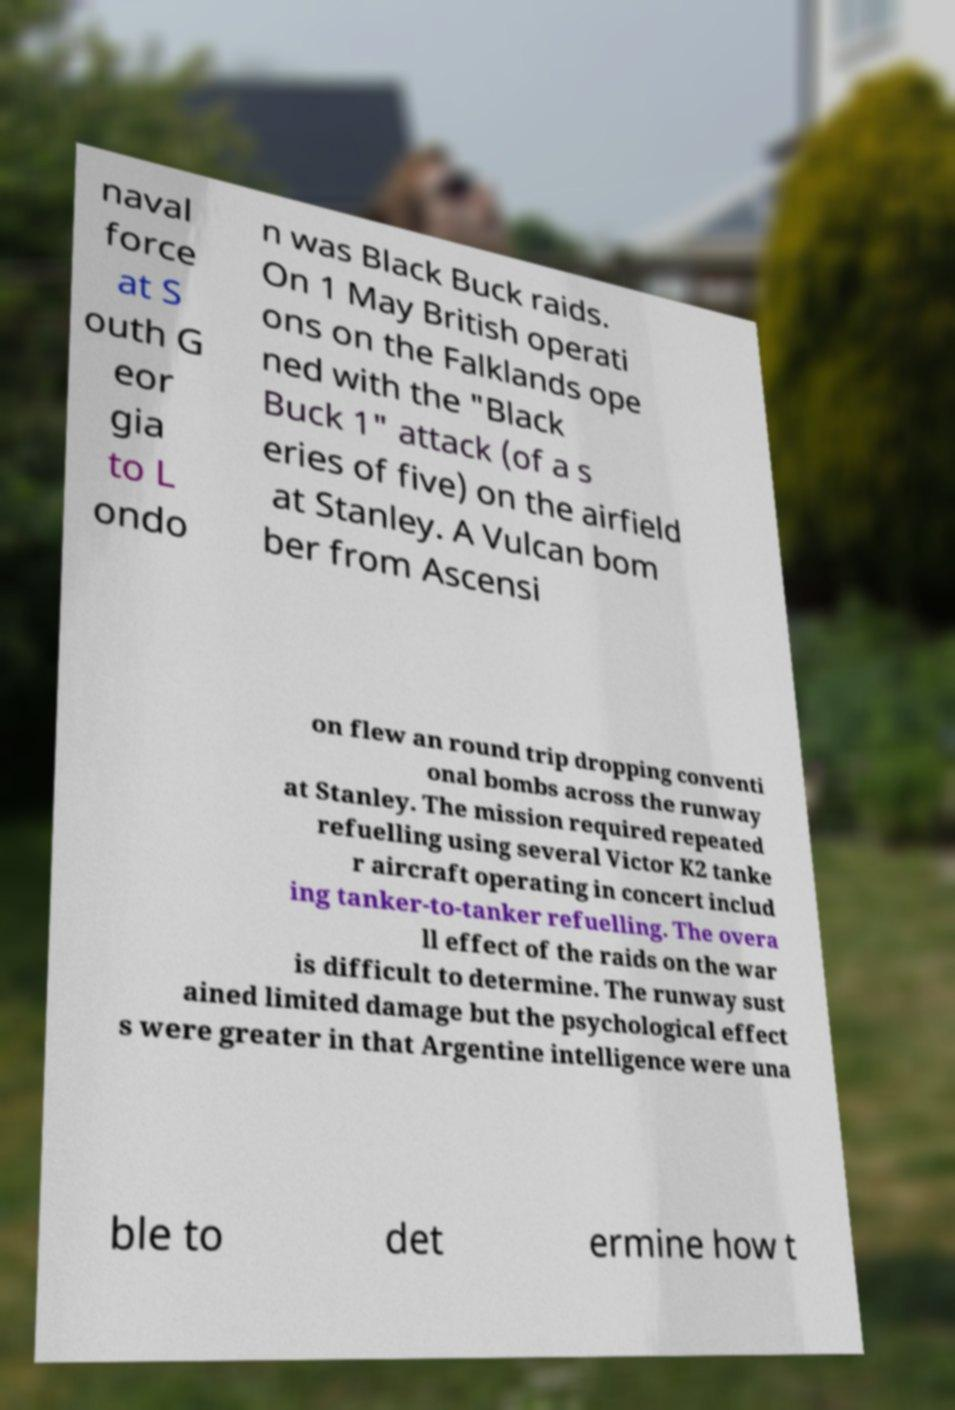Can you read and provide the text displayed in the image?This photo seems to have some interesting text. Can you extract and type it out for me? naval force at S outh G eor gia to L ondo n was Black Buck raids. On 1 May British operati ons on the Falklands ope ned with the "Black Buck 1" attack (of a s eries of five) on the airfield at Stanley. A Vulcan bom ber from Ascensi on flew an round trip dropping conventi onal bombs across the runway at Stanley. The mission required repeated refuelling using several Victor K2 tanke r aircraft operating in concert includ ing tanker-to-tanker refuelling. The overa ll effect of the raids on the war is difficult to determine. The runway sust ained limited damage but the psychological effect s were greater in that Argentine intelligence were una ble to det ermine how t 